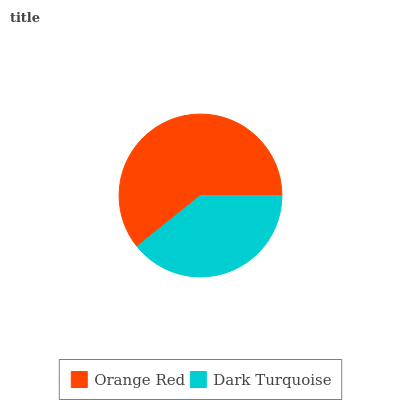Is Dark Turquoise the minimum?
Answer yes or no. Yes. Is Orange Red the maximum?
Answer yes or no. Yes. Is Dark Turquoise the maximum?
Answer yes or no. No. Is Orange Red greater than Dark Turquoise?
Answer yes or no. Yes. Is Dark Turquoise less than Orange Red?
Answer yes or no. Yes. Is Dark Turquoise greater than Orange Red?
Answer yes or no. No. Is Orange Red less than Dark Turquoise?
Answer yes or no. No. Is Orange Red the high median?
Answer yes or no. Yes. Is Dark Turquoise the low median?
Answer yes or no. Yes. Is Dark Turquoise the high median?
Answer yes or no. No. Is Orange Red the low median?
Answer yes or no. No. 